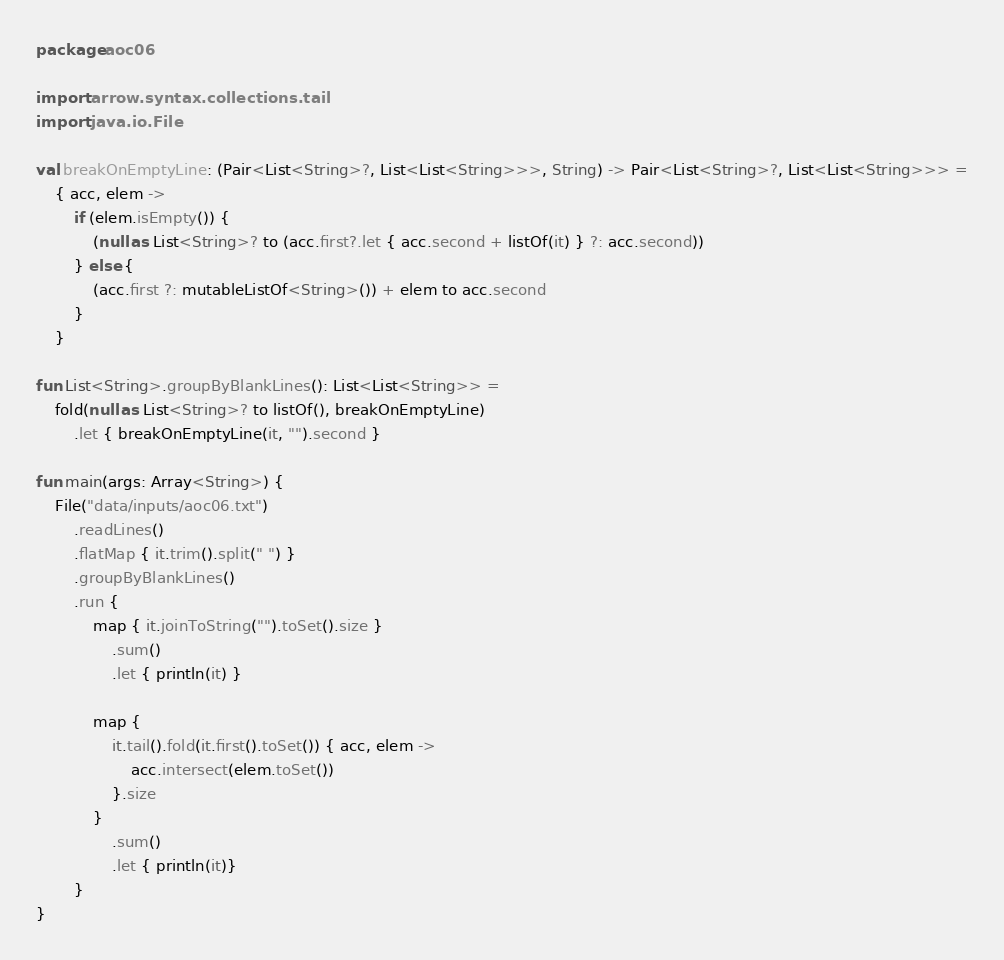<code> <loc_0><loc_0><loc_500><loc_500><_Kotlin_>package aoc06

import arrow.syntax.collections.tail
import java.io.File

val breakOnEmptyLine: (Pair<List<String>?, List<List<String>>>, String) -> Pair<List<String>?, List<List<String>>> =
    { acc, elem ->
        if (elem.isEmpty()) {
            (null as List<String>? to (acc.first?.let { acc.second + listOf(it) } ?: acc.second))
        } else {
            (acc.first ?: mutableListOf<String>()) + elem to acc.second
        }
    }

fun List<String>.groupByBlankLines(): List<List<String>> =
    fold(null as List<String>? to listOf(), breakOnEmptyLine)
        .let { breakOnEmptyLine(it, "").second }

fun main(args: Array<String>) {
    File("data/inputs/aoc06.txt")
        .readLines()
        .flatMap { it.trim().split(" ") }
        .groupByBlankLines()
        .run {
            map { it.joinToString("").toSet().size }
                .sum()
                .let { println(it) }

            map {
                it.tail().fold(it.first().toSet()) { acc, elem ->
                    acc.intersect(elem.toSet())
                }.size
            }
                .sum()
                .let { println(it)}
        }
}</code> 